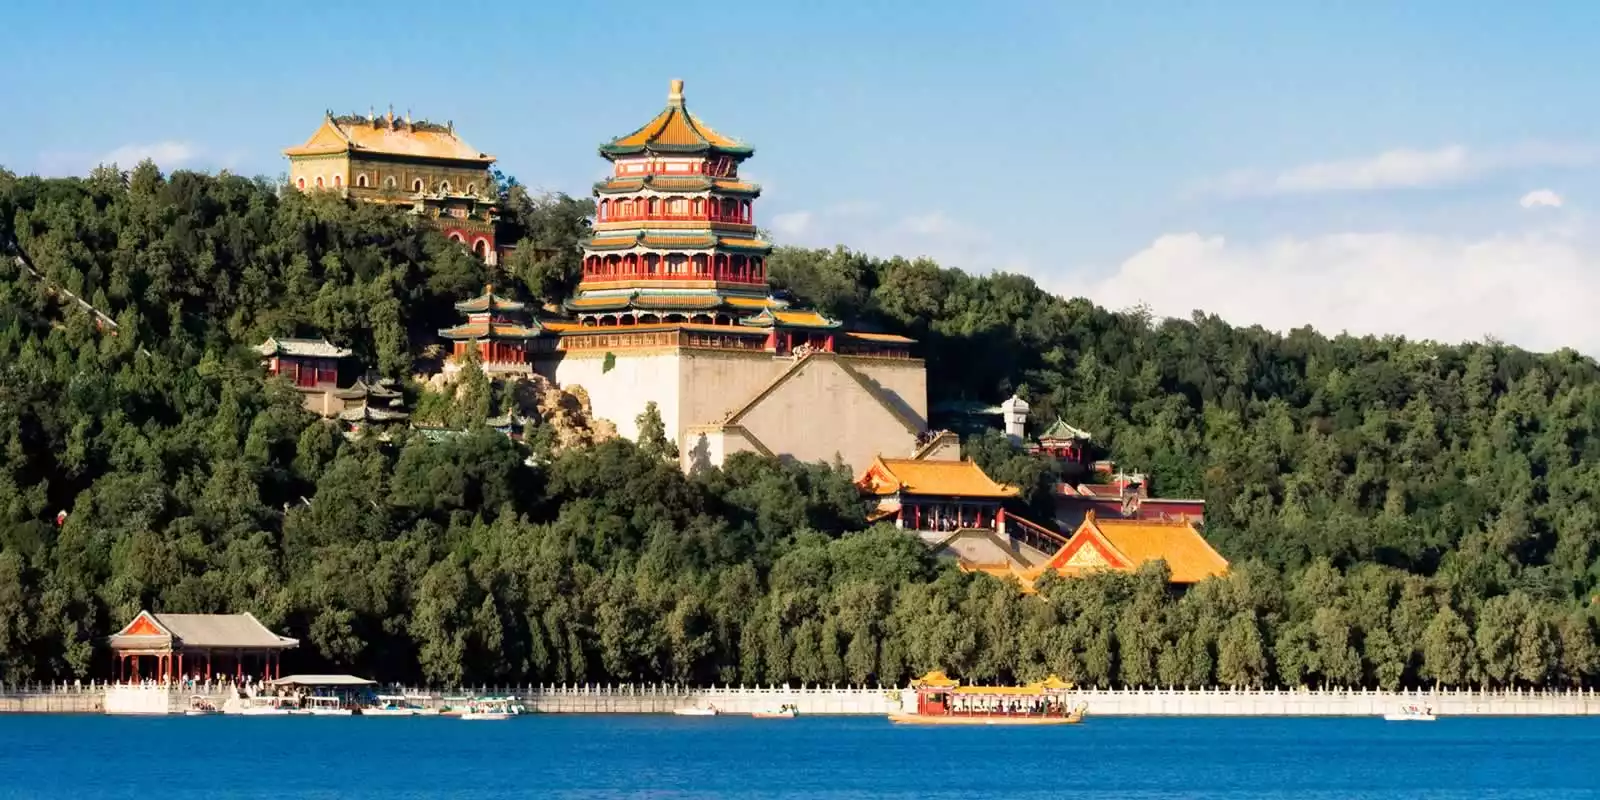Can you describe the main features of this image for me? The image captures the stunning beauty of the Summer Palace in China, viewed from across a serene blue lake. The palace complex stands majestically with its exquisite and colorful architecture, having an array of red, yellow, and green roofs that embody traditional Chinese aesthetics. The primary structure, known as the Tower of Buddhist Incense, rises prominently, creating a striking focal point against the clear, blue sky. Dotted around the palace, numerous smaller buildings and pavilions blend harmoniously with the lush greenery of the surrounding trees. Boats can be seen gently moving across the sparkling surface of the lake, enhancing the tranquil and lively ambiance of the scene. Overall, the photo offers a comprehensive view of this iconic landmark, highlighting its grandiosity, elegance, and the serene natural environment encasing it. 